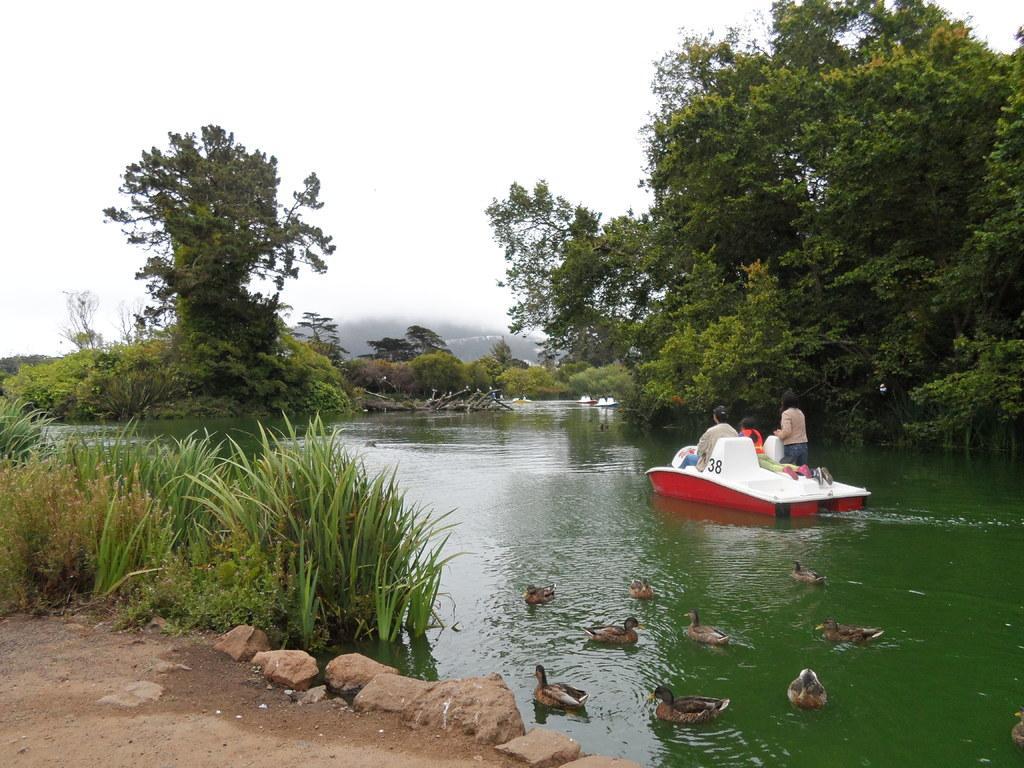How would you summarize this image in a sentence or two? Bottom right side of the image there is water, on the water there are some ducks and ship. In the ship few people are sitting. Top right side of the image there are some trees. Top left side of the image there are some trees. Behind the trees there are some clouds and sky. Bottom left side of the image there are some stones and grass. 